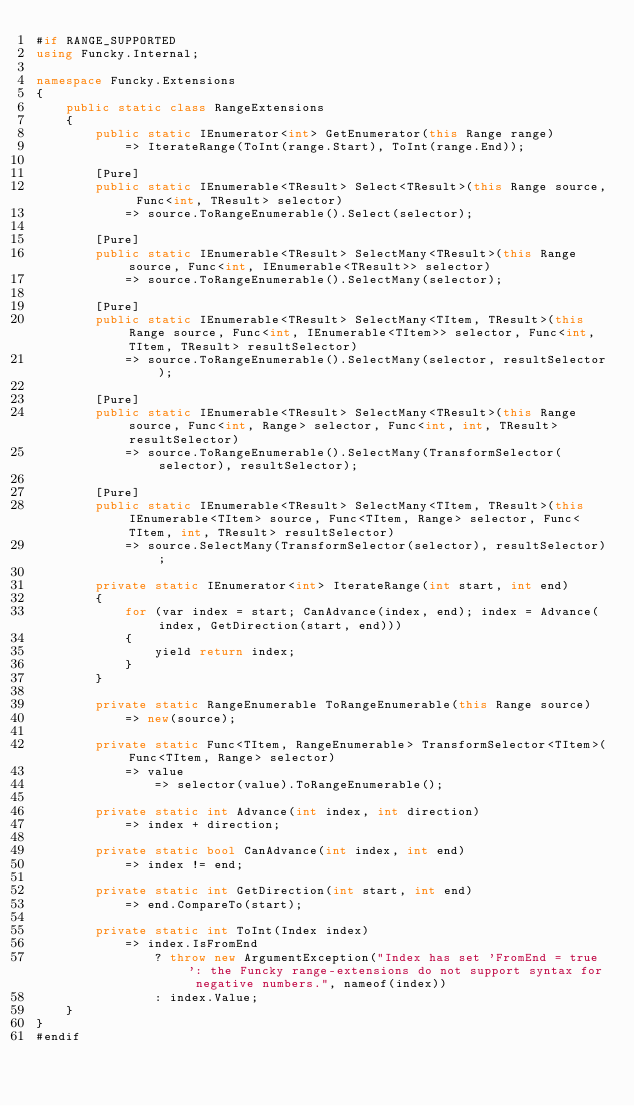<code> <loc_0><loc_0><loc_500><loc_500><_C#_>#if RANGE_SUPPORTED
using Funcky.Internal;

namespace Funcky.Extensions
{
    public static class RangeExtensions
    {
        public static IEnumerator<int> GetEnumerator(this Range range)
            => IterateRange(ToInt(range.Start), ToInt(range.End));

        [Pure]
        public static IEnumerable<TResult> Select<TResult>(this Range source, Func<int, TResult> selector)
            => source.ToRangeEnumerable().Select(selector);

        [Pure]
        public static IEnumerable<TResult> SelectMany<TResult>(this Range source, Func<int, IEnumerable<TResult>> selector)
            => source.ToRangeEnumerable().SelectMany(selector);

        [Pure]
        public static IEnumerable<TResult> SelectMany<TItem, TResult>(this Range source, Func<int, IEnumerable<TItem>> selector, Func<int, TItem, TResult> resultSelector)
            => source.ToRangeEnumerable().SelectMany(selector, resultSelector);

        [Pure]
        public static IEnumerable<TResult> SelectMany<TResult>(this Range source, Func<int, Range> selector, Func<int, int, TResult> resultSelector)
            => source.ToRangeEnumerable().SelectMany(TransformSelector(selector), resultSelector);

        [Pure]
        public static IEnumerable<TResult> SelectMany<TItem, TResult>(this IEnumerable<TItem> source, Func<TItem, Range> selector, Func<TItem, int, TResult> resultSelector)
            => source.SelectMany(TransformSelector(selector), resultSelector);

        private static IEnumerator<int> IterateRange(int start, int end)
        {
            for (var index = start; CanAdvance(index, end); index = Advance(index, GetDirection(start, end)))
            {
                yield return index;
            }
        }

        private static RangeEnumerable ToRangeEnumerable(this Range source)
            => new(source);

        private static Func<TItem, RangeEnumerable> TransformSelector<TItem>(Func<TItem, Range> selector)
            => value
                => selector(value).ToRangeEnumerable();

        private static int Advance(int index, int direction)
            => index + direction;

        private static bool CanAdvance(int index, int end)
            => index != end;

        private static int GetDirection(int start, int end)
            => end.CompareTo(start);

        private static int ToInt(Index index)
            => index.IsFromEnd
                ? throw new ArgumentException("Index has set 'FromEnd = true': the Funcky range-extensions do not support syntax for negative numbers.", nameof(index))
                : index.Value;
    }
}
#endif
</code> 